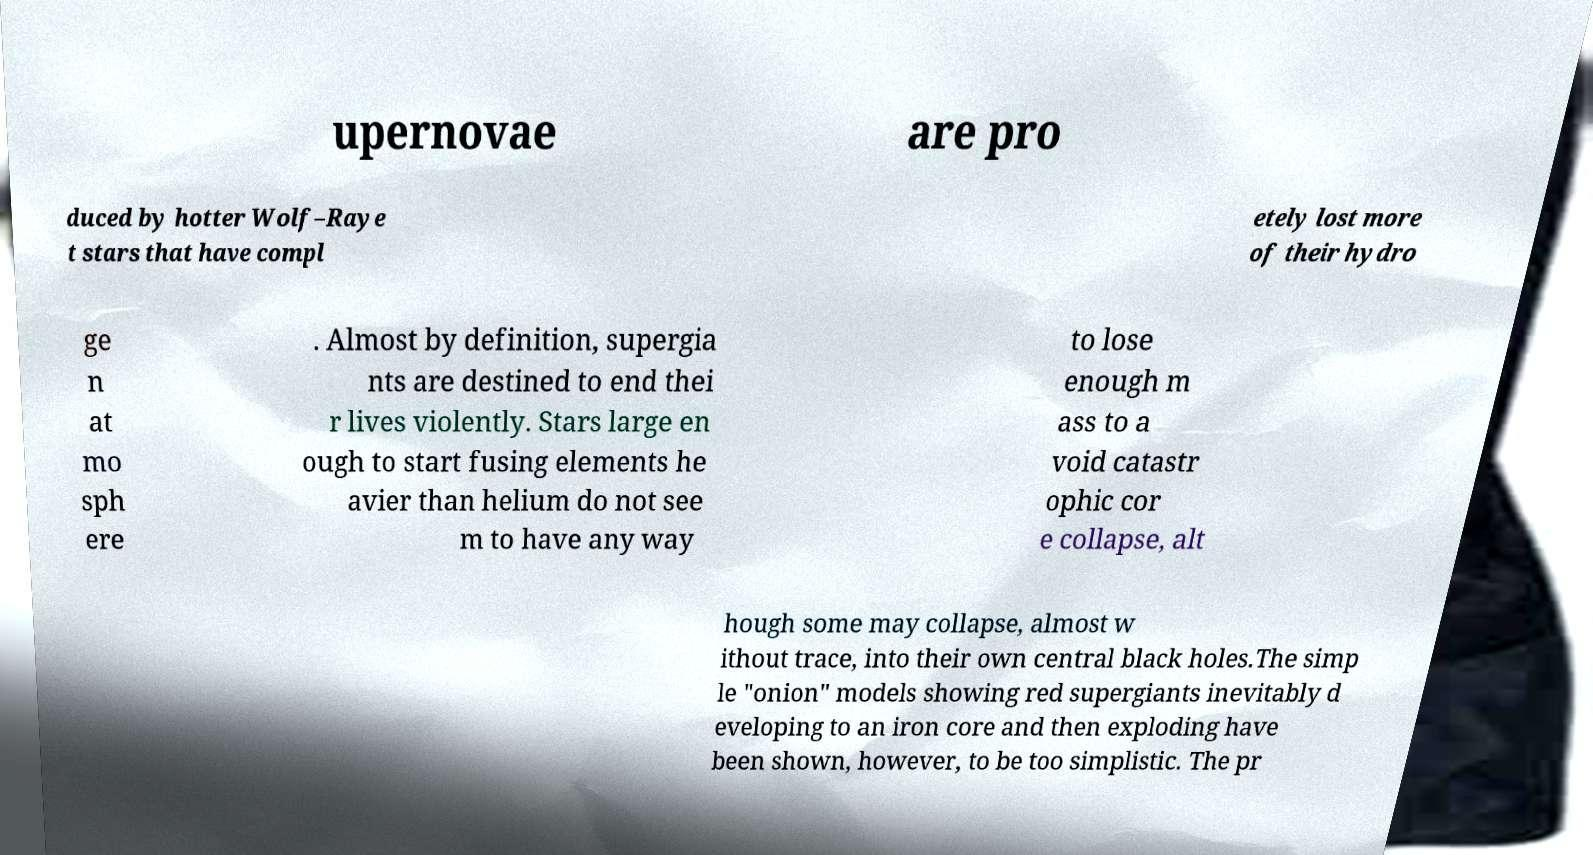I need the written content from this picture converted into text. Can you do that? upernovae are pro duced by hotter Wolf–Raye t stars that have compl etely lost more of their hydro ge n at mo sph ere . Almost by definition, supergia nts are destined to end thei r lives violently. Stars large en ough to start fusing elements he avier than helium do not see m to have any way to lose enough m ass to a void catastr ophic cor e collapse, alt hough some may collapse, almost w ithout trace, into their own central black holes.The simp le "onion" models showing red supergiants inevitably d eveloping to an iron core and then exploding have been shown, however, to be too simplistic. The pr 